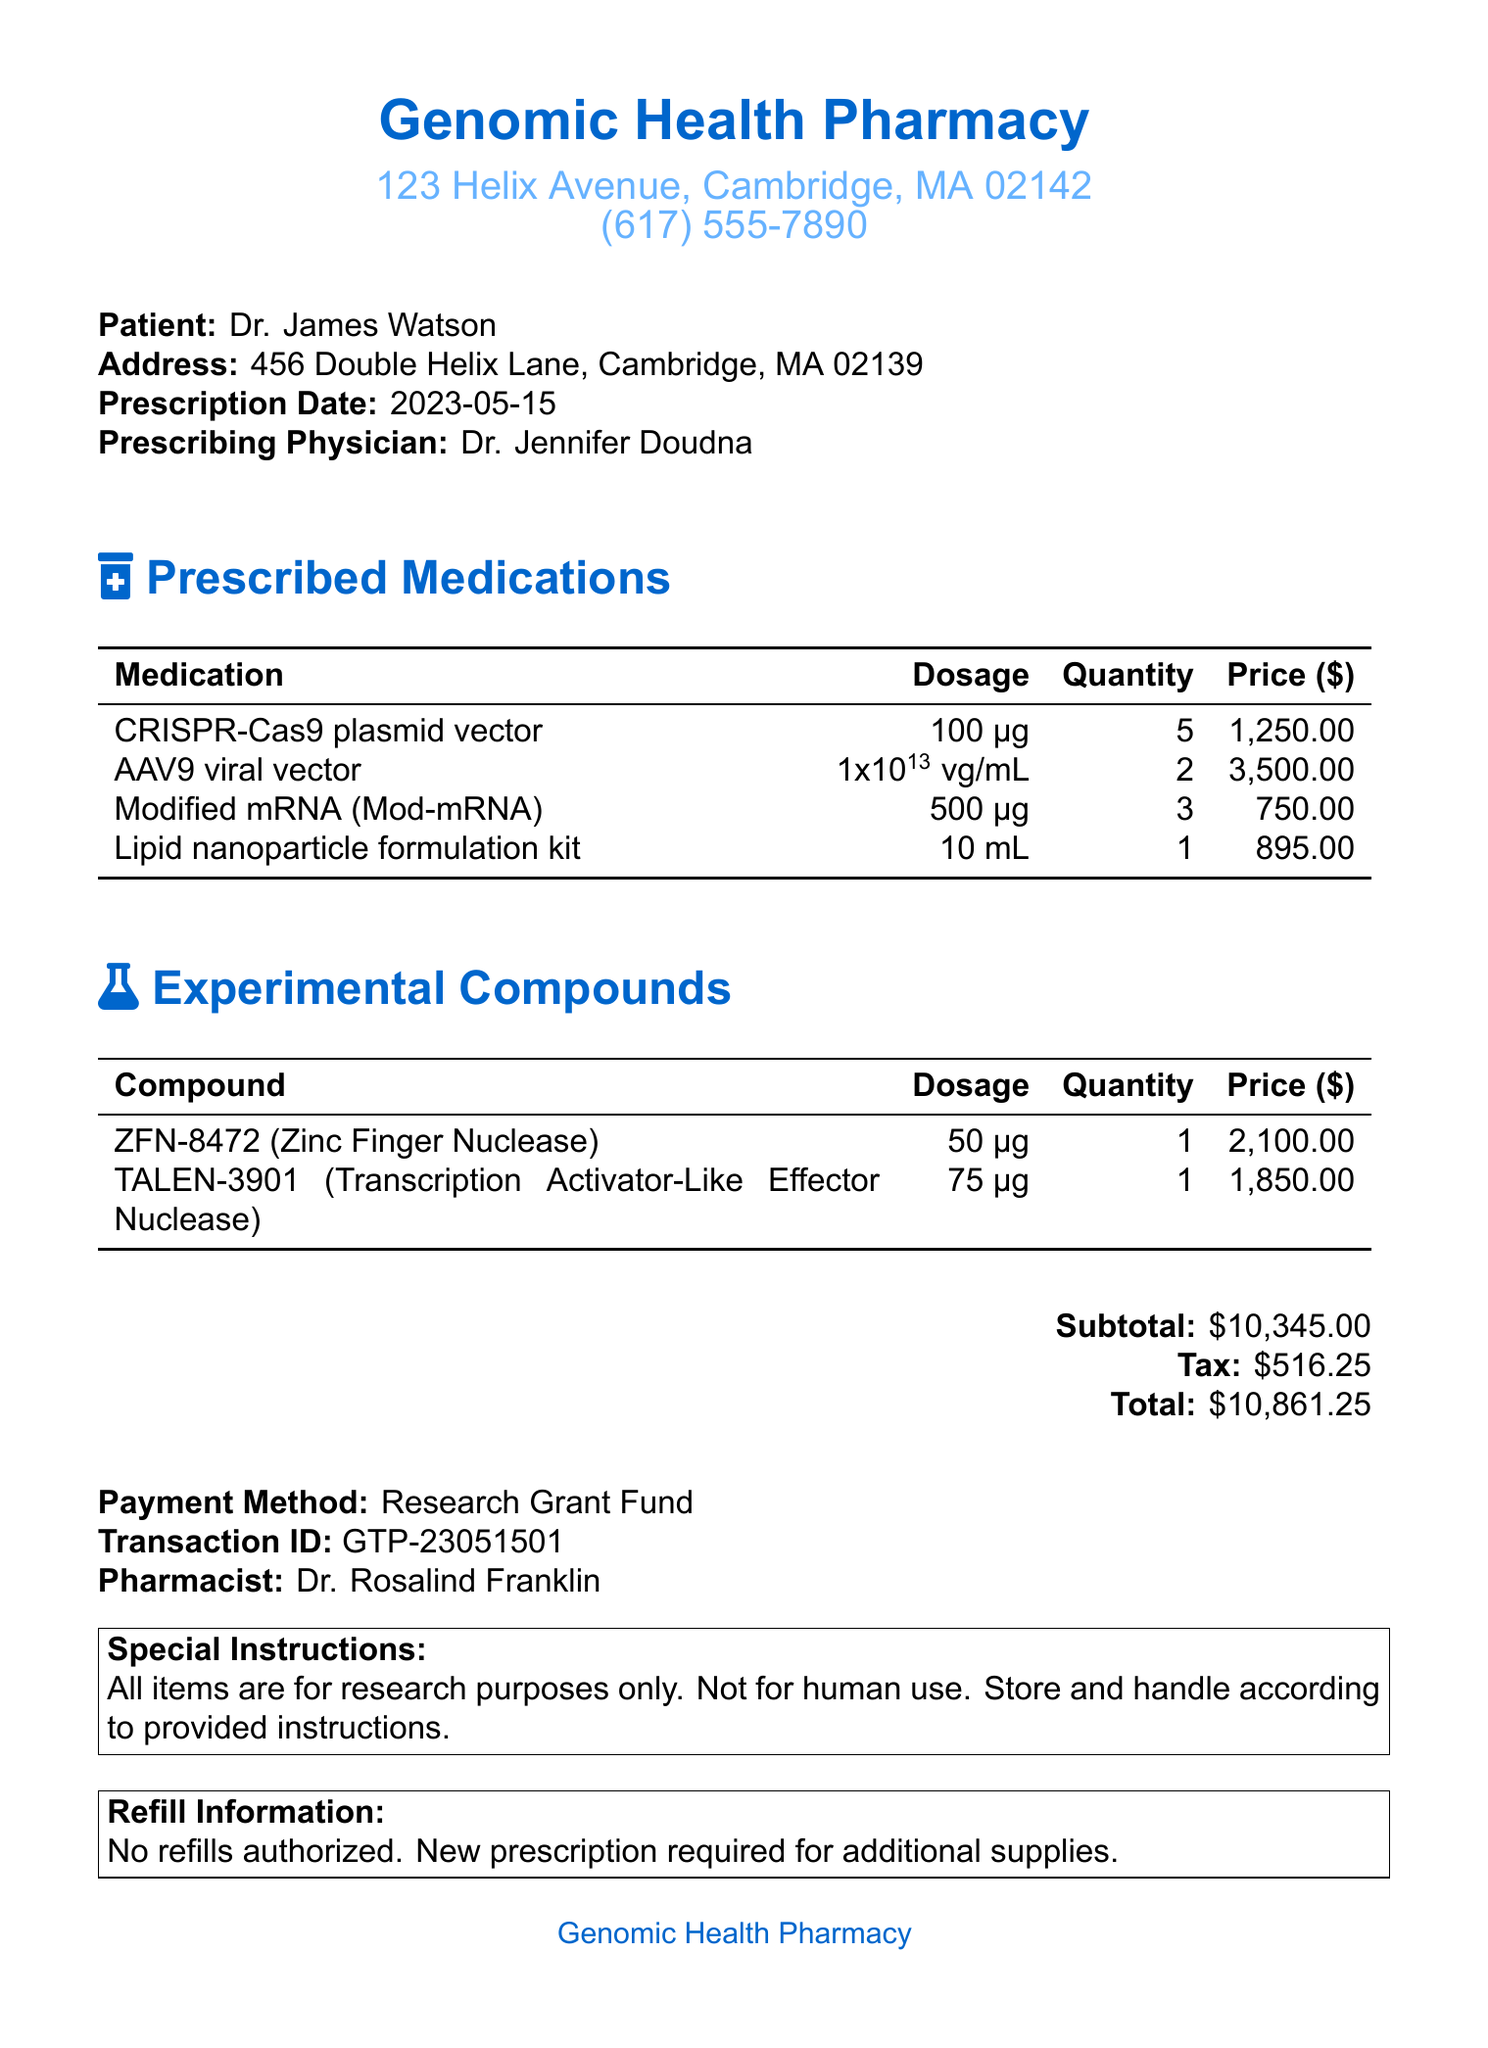what is the pharmacy name? The pharmacy name is listed at the top of the document.
Answer: Genomic Health Pharmacy who is the prescribing physician? The prescribing physician is mentioned under the patient's details.
Answer: Dr. Jennifer Doudna what is the total amount due? The total amount due is summarized at the bottom of the receipt.
Answer: 10,861.25 how many units of AAV9 viral vector were prescribed? The quantity of AAV9 viral vector is specified in the medications table.
Answer: 2 what is the dosage of ZFN-8472? The dosage information for each experimental compound is provided in the respective table.
Answer: 50 μg what payment method was used? The payment method is stated towards the end of the document.
Answer: Research Grant Fund what is the transaction ID? The transaction ID can be found near the payment method at the bottom.
Answer: GTP-23051501 how many types of experimental compounds are listed? The document lists the experimental compounds in a dedicated section.
Answer: 2 what storage temperature is recommended for the lipid nanoparticle formulation kit? Storage instructions for the lipid nanoparticle formulation kit are mentioned in its details.
Answer: -20°C 